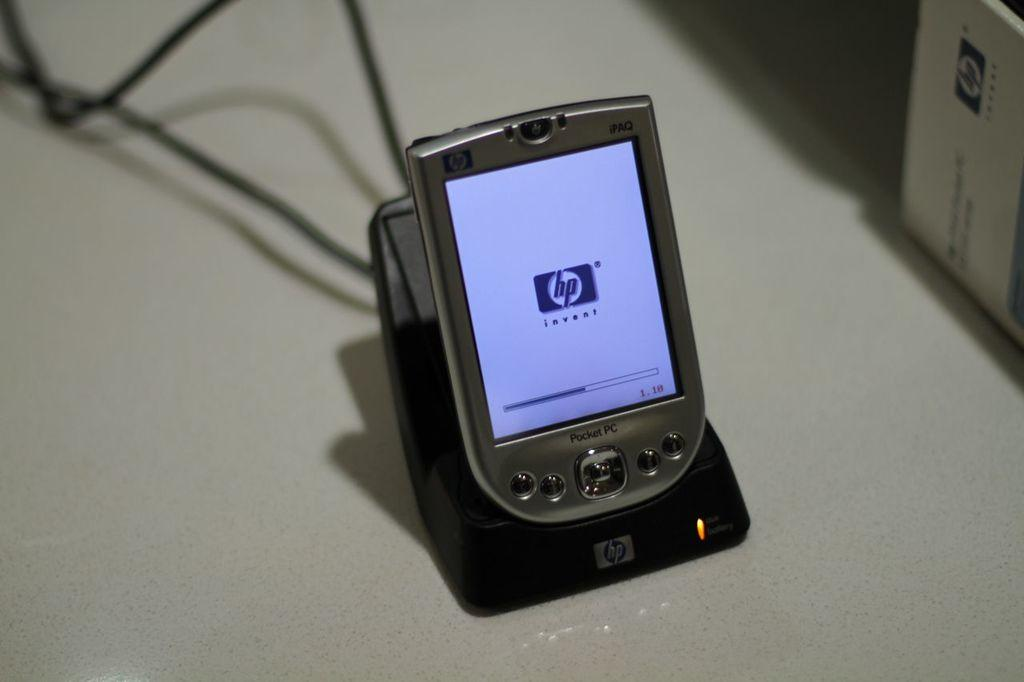<image>
Write a terse but informative summary of the picture. A HP Pocket PC on an HP charging dock. 